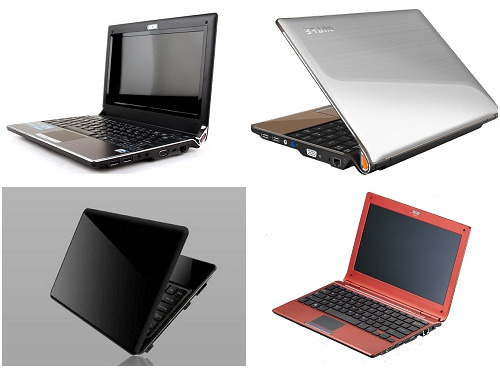Describe the objects in this image and their specific colors. I can see laptop in white, darkgray, lightgray, black, and gray tones, laptop in white, black, and gray tones, laptop in white, gray, black, salmon, and brown tones, and laptop in white, black, gray, and darkgray tones in this image. 